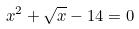<formula> <loc_0><loc_0><loc_500><loc_500>x ^ { 2 } + \sqrt { x } - 1 4 = 0</formula> 